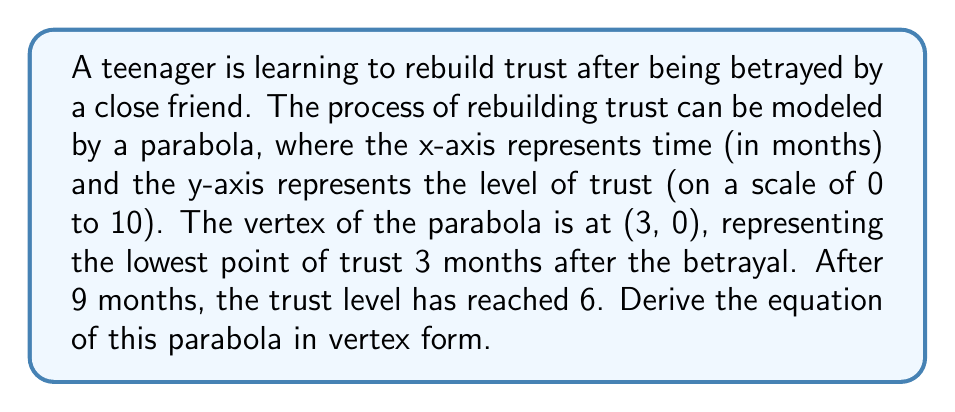What is the answer to this math problem? Let's approach this step-by-step:

1) The vertex form of a parabola is given by:
   $$y = a(x - h)^2 + k$$
   where (h, k) is the vertex of the parabola.

2) We know the vertex is at (3, 0), so h = 3 and k = 0. Our equation becomes:
   $$y = a(x - 3)^2$$

3) We need to find the value of a. We can use the point (9, 6) to do this:
   $$6 = a(9 - 3)^2$$
   $$6 = a(6)^2$$
   $$6 = 36a$$

4) Solving for a:
   $$a = \frac{6}{36} = \frac{1}{6}$$

5) Now we can write our final equation by substituting a = 1/6:
   $$y = \frac{1}{6}(x - 3)^2$$

This parabola opens upward, representing the gradual rebuilding of trust over time.
Answer: $$y = \frac{1}{6}(x - 3)^2$$ 